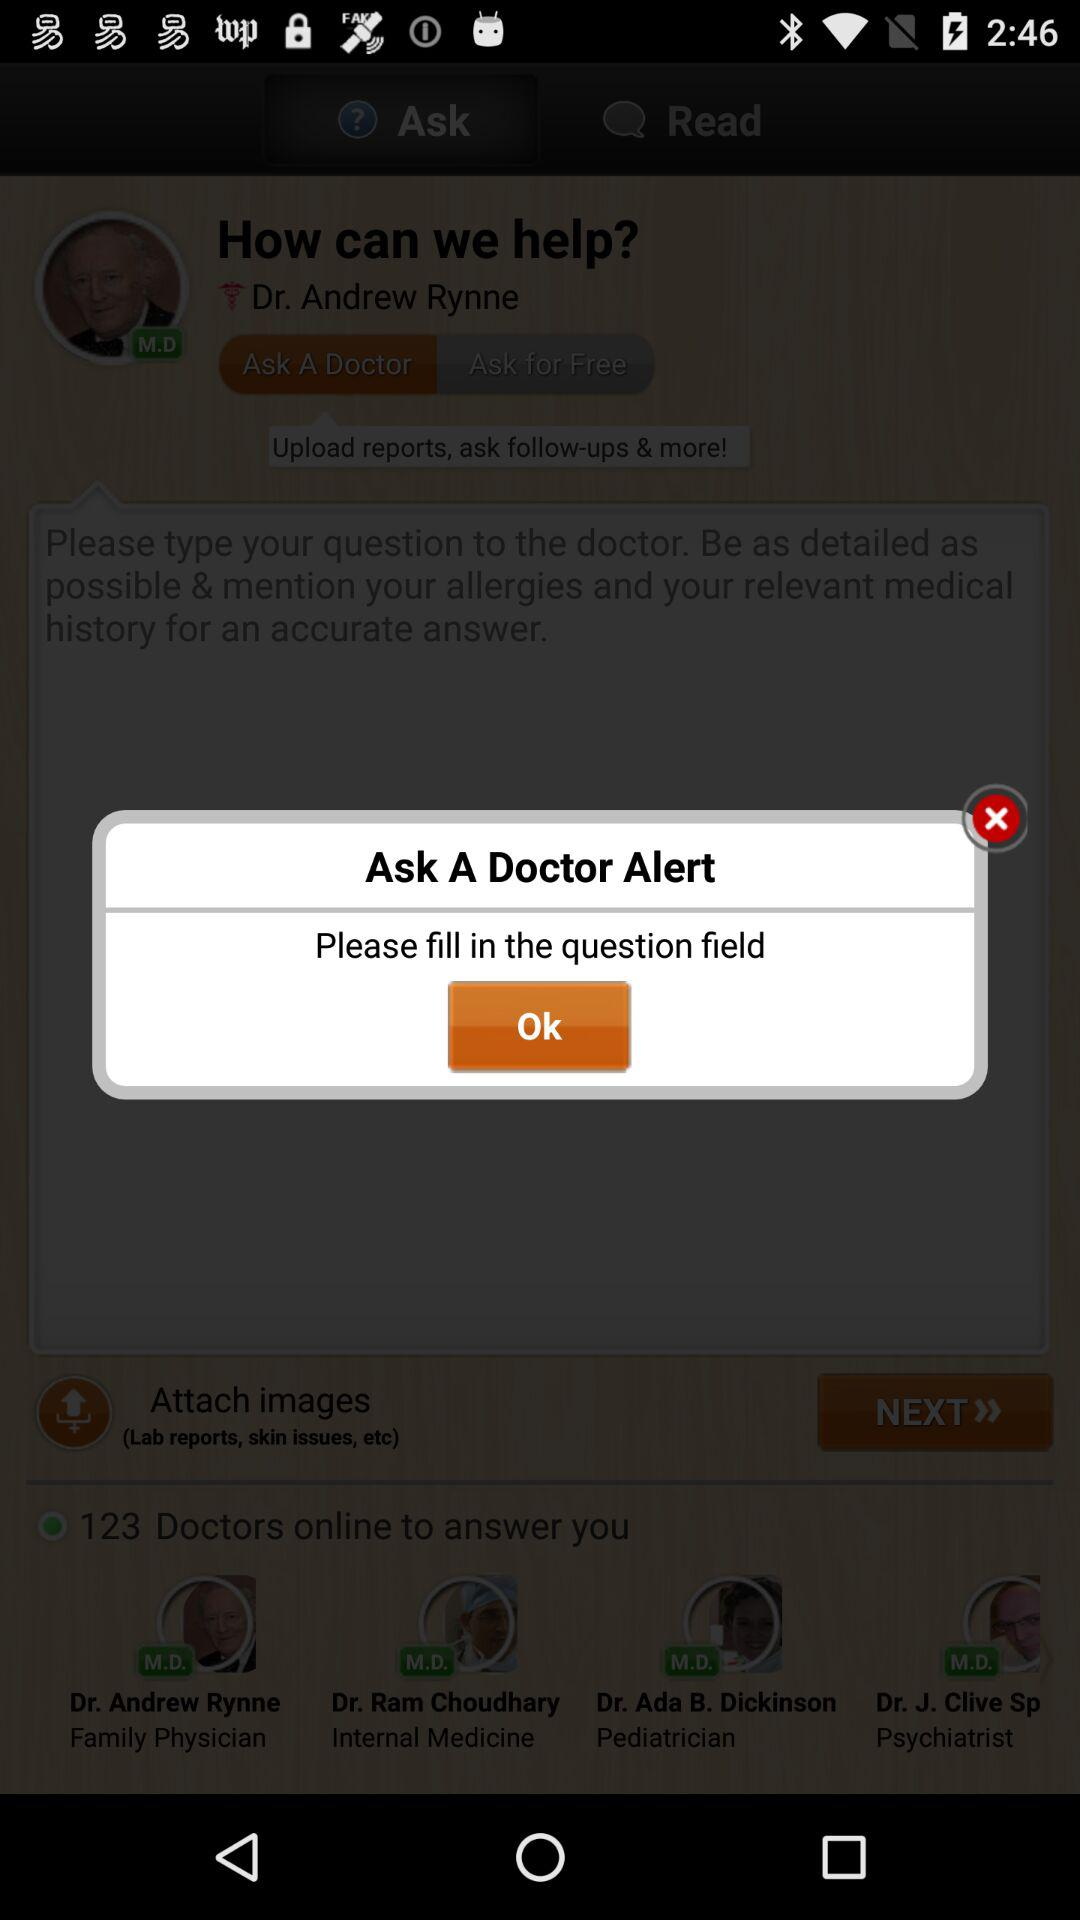How many doctors are online to answer? The number of doctors that are online to answer is 123. 